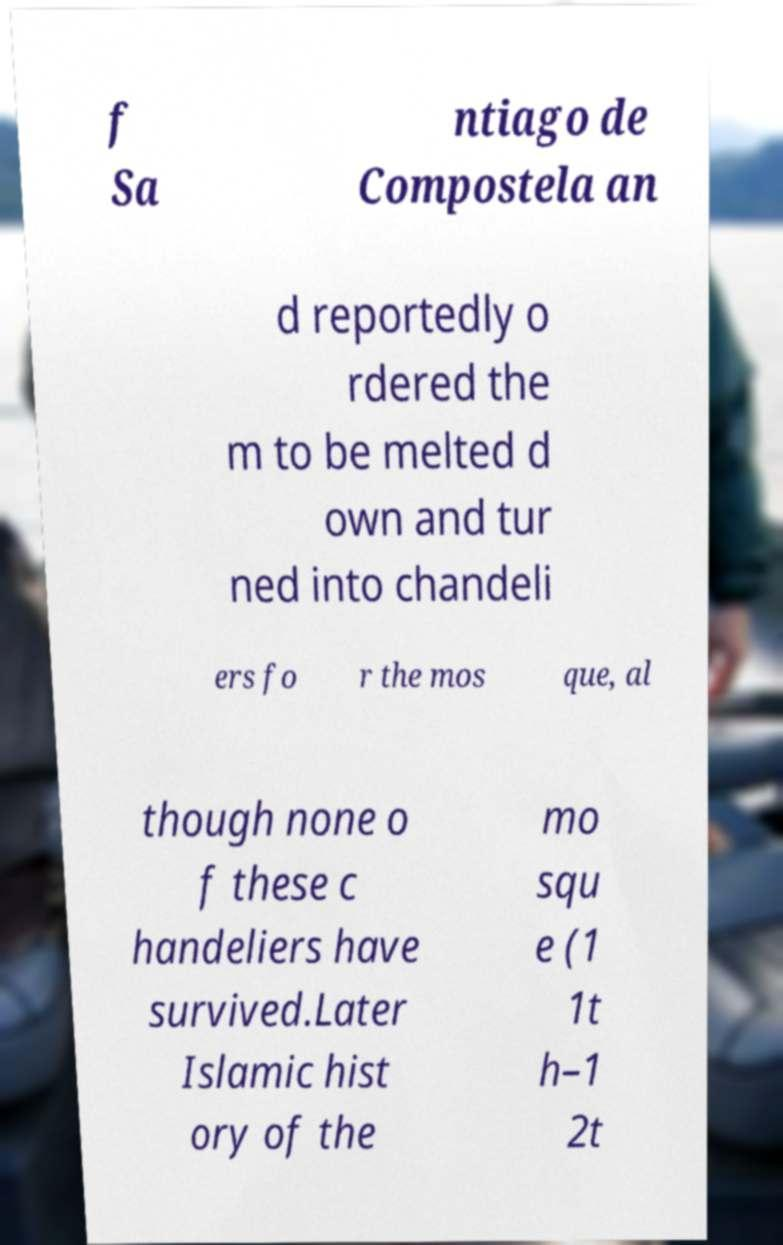Could you assist in decoding the text presented in this image and type it out clearly? f Sa ntiago de Compostela an d reportedly o rdered the m to be melted d own and tur ned into chandeli ers fo r the mos que, al though none o f these c handeliers have survived.Later Islamic hist ory of the mo squ e (1 1t h–1 2t 